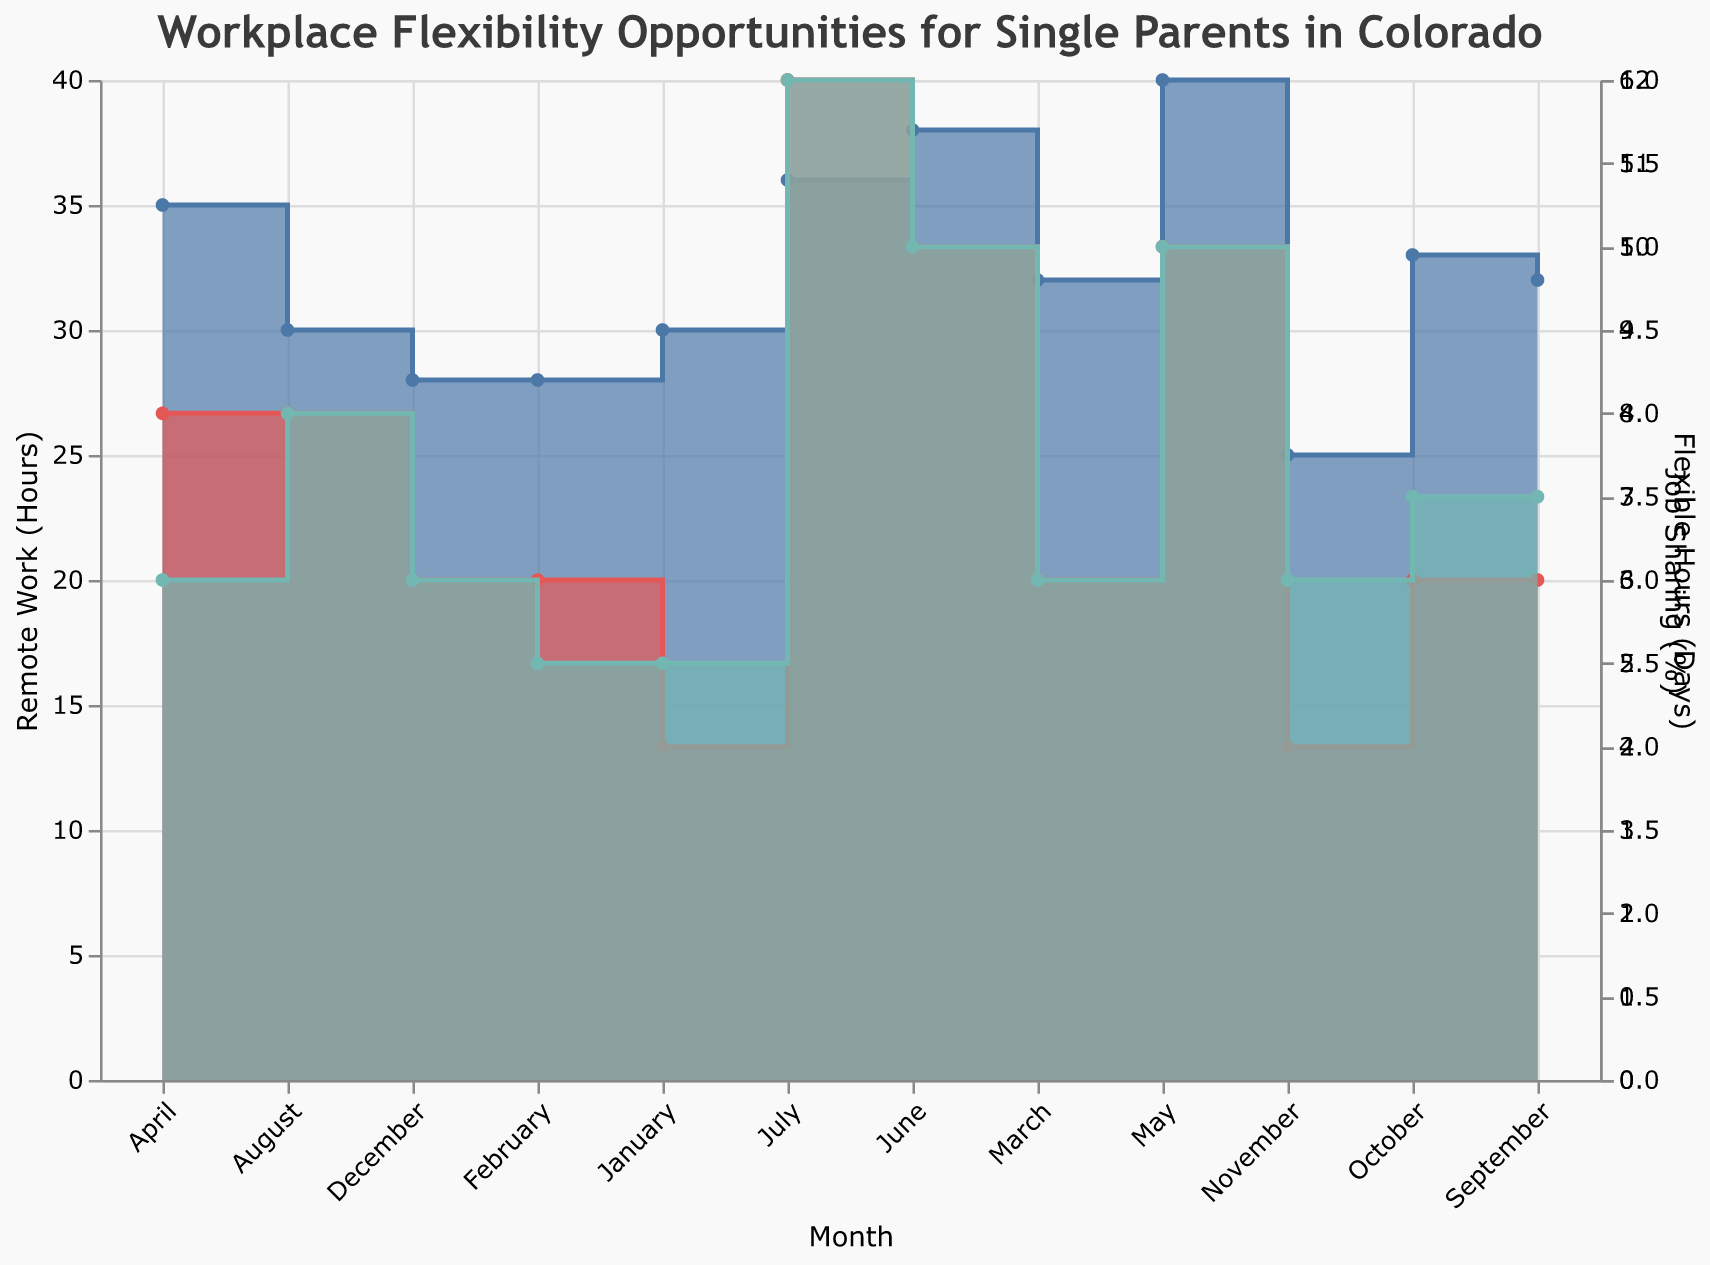what is the title of the Step Area Chart? The title is usually located at the top of the chart and provides a summary of the content. In this case, it reads "Workplace Flexibility Opportunities for Single Parents in Colorado" as indicated in the provided chart code.
Answer: Workplace Flexibility Opportunities for Single Parents in Colorado Which month has the highest remote work hours for Tech Innovators? By examining the plot for Tech Innovators' entries and looking at the Remote Work (Hours) axis, we can see that May has the highest value of 40 hours.
Answer: May Which workplace offers the most flexible hours, and in which month? By comparing the Flexible Hours (Days) across all months and workplaces, we find that Tech Innovators in July offers the most with 6 days.
Answer: Tech Innovators in July What is the range of job sharing percent offered by Green Solutions? Range is calculated by finding the difference between the maximum and minimum values. For Green Solutions, the maximum is 8% (August) and minimum is 7% (September, October), so the range is 1.
Answer: 1% How does the number of remote work hours change from March to April for ACME Corp? Look at the points on the chart for ACME Corp in March and April, the remote work hours increase from 32 to 35 hours. The change is 35 - 32 = +3 hours.
Answer: +3 hours Which month shows the least remote work hours across all workplaces, and what is the value? The lowest remote work hours value across all months and workplaces is seen in November with Health Services Inc. at 25 hours.
Answer: November, 25 hours Between August and September, how did the number of flexible hours change for Green Solutions? From the chart, Green Solutions' flexible hours decreased from 4 days in August to 3 days in September. The change is 4 - 3 = -1 day.
Answer: -1 day How do job sharing percentages compare between ACME Corp in January and Health Services Inc. in December? Comparing the job sharing values, ACME Corp in January has 5% and Health Services Inc. in December has 6%. 6% - 5% = +1% higher for Health Services Inc.
Answer: Health Services Inc. is higher by 1% During which month do all workplaces have the same number of flexible hours? By examining the plot for all workplaces, April shows all workplaces with a flexible hours value between 3-4 days, but no exact uniformity. This does not happen exactly in any single month.
Answer: No such month 